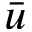<formula> <loc_0><loc_0><loc_500><loc_500>\bar { u }</formula> 